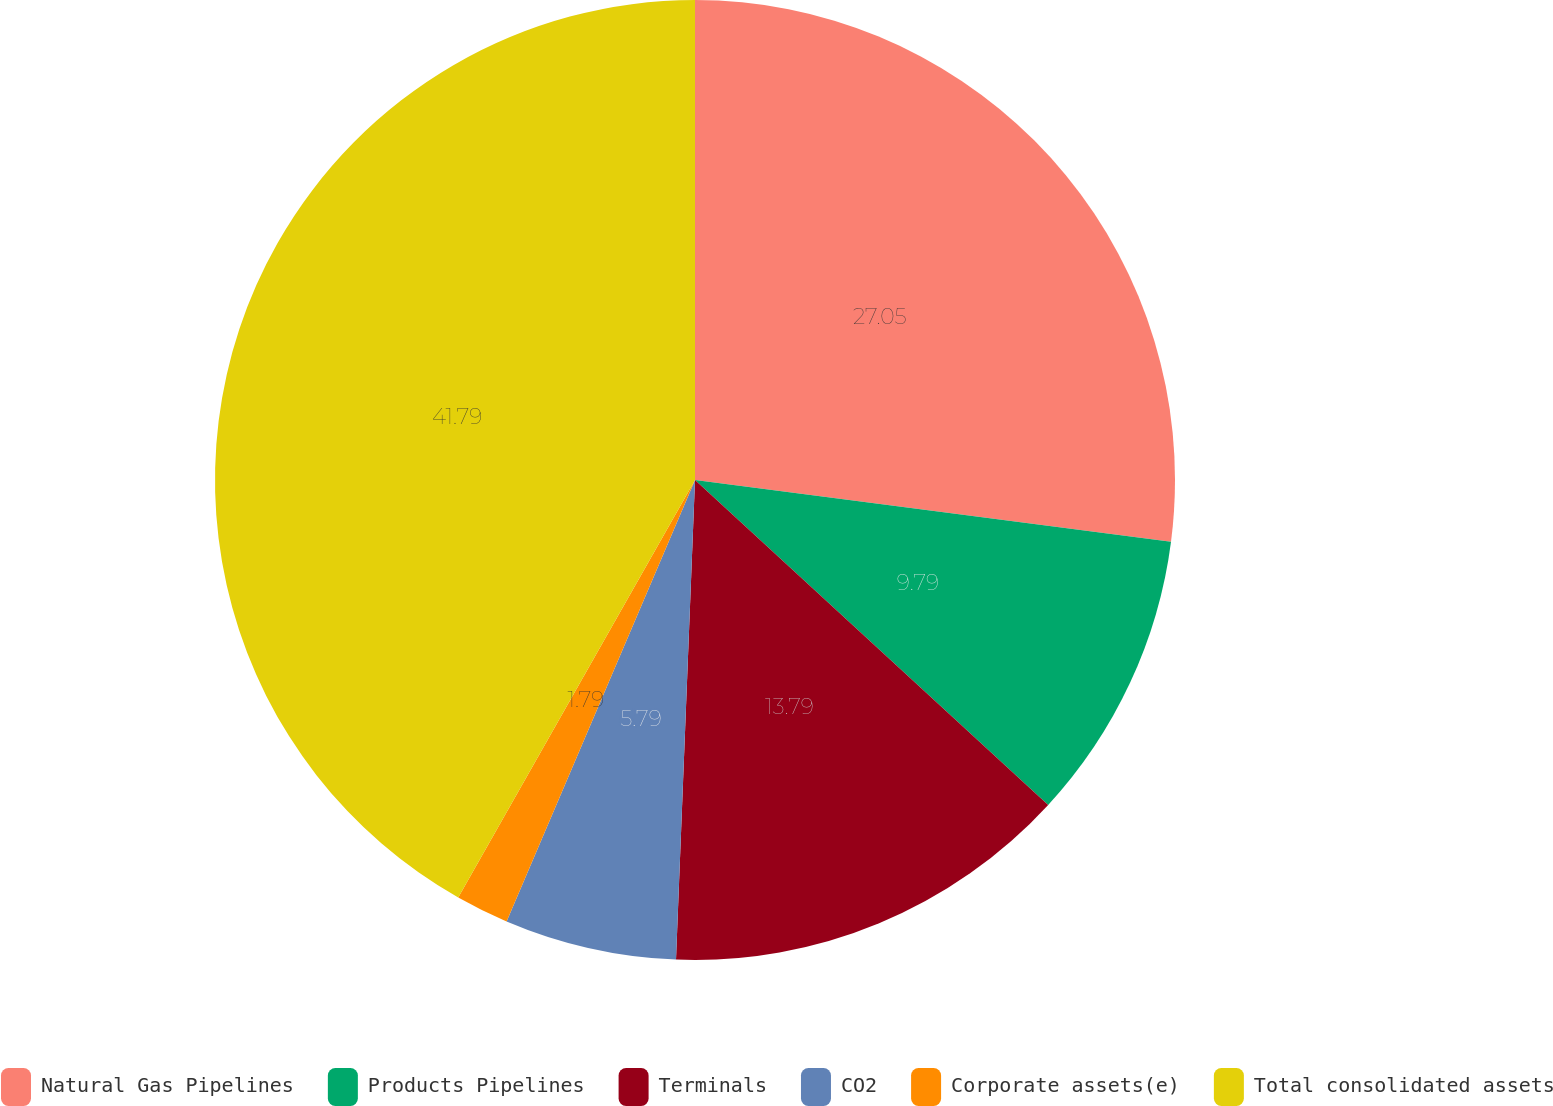Convert chart to OTSL. <chart><loc_0><loc_0><loc_500><loc_500><pie_chart><fcel>Natural Gas Pipelines<fcel>Products Pipelines<fcel>Terminals<fcel>CO2<fcel>Corporate assets(e)<fcel>Total consolidated assets<nl><fcel>27.05%<fcel>9.79%<fcel>13.79%<fcel>5.79%<fcel>1.79%<fcel>41.79%<nl></chart> 